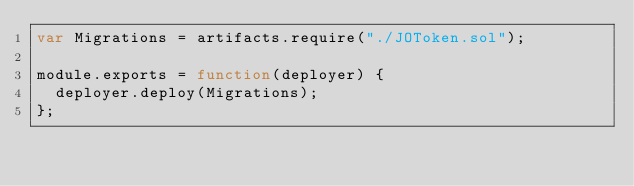<code> <loc_0><loc_0><loc_500><loc_500><_JavaScript_>var Migrations = artifacts.require("./JOToken.sol");

module.exports = function(deployer) {
  deployer.deploy(Migrations);
};
</code> 